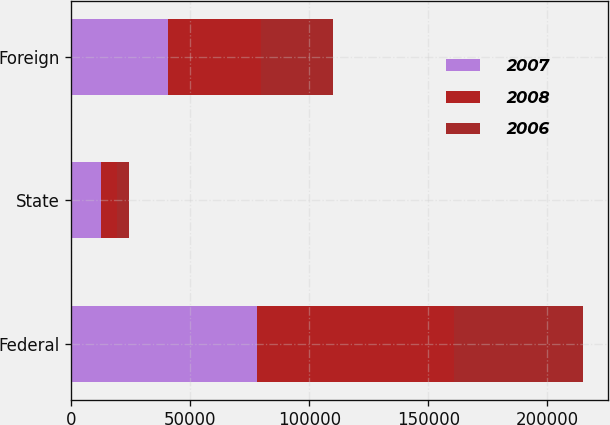<chart> <loc_0><loc_0><loc_500><loc_500><stacked_bar_chart><ecel><fcel>Federal<fcel>State<fcel>Foreign<nl><fcel>2007<fcel>77920<fcel>12309<fcel>40739<nl><fcel>2008<fcel>82923<fcel>6940<fcel>39062<nl><fcel>2006<fcel>53937<fcel>4896<fcel>29942<nl></chart> 